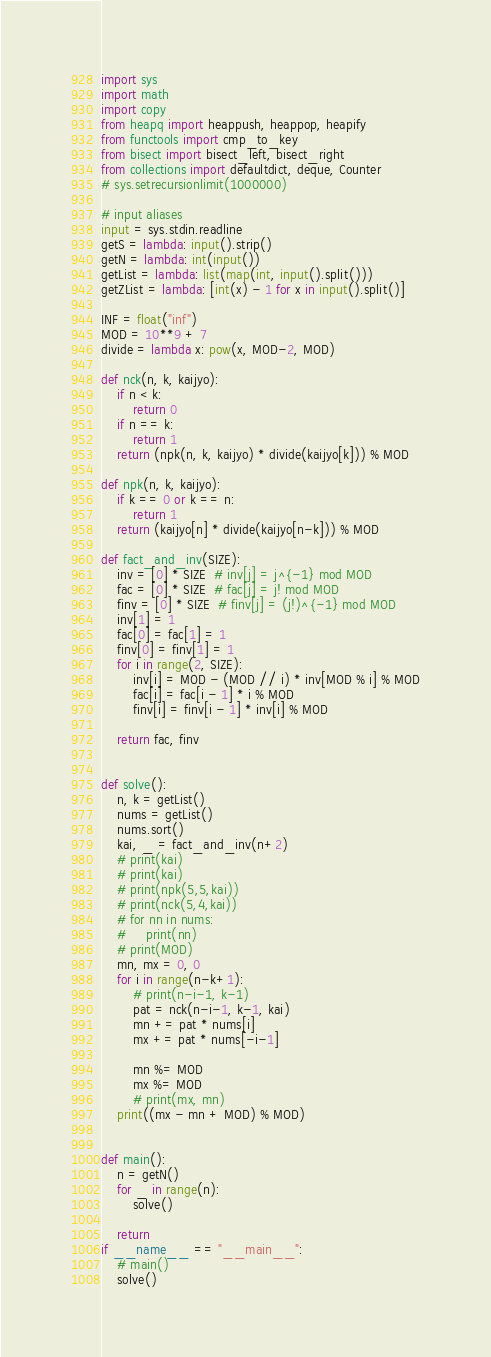<code> <loc_0><loc_0><loc_500><loc_500><_Python_>import sys
import math
import copy
from heapq import heappush, heappop, heapify
from functools import cmp_to_key
from bisect import bisect_left, bisect_right
from collections import defaultdict, deque, Counter
# sys.setrecursionlimit(1000000)

# input aliases
input = sys.stdin.readline
getS = lambda: input().strip()
getN = lambda: int(input())
getList = lambda: list(map(int, input().split()))
getZList = lambda: [int(x) - 1 for x in input().split()]

INF = float("inf")
MOD = 10**9 + 7
divide = lambda x: pow(x, MOD-2, MOD)

def nck(n, k, kaijyo):
    if n < k:
        return 0
    if n == k:
        return 1
    return (npk(n, k, kaijyo) * divide(kaijyo[k])) % MOD

def npk(n, k, kaijyo):
    if k == 0 or k == n:
        return 1
    return (kaijyo[n] * divide(kaijyo[n-k])) % MOD

def fact_and_inv(SIZE):
    inv = [0] * SIZE  # inv[j] = j^{-1} mod MOD
    fac = [0] * SIZE  # fac[j] = j! mod MOD
    finv = [0] * SIZE  # finv[j] = (j!)^{-1} mod MOD
    inv[1] = 1
    fac[0] = fac[1] = 1
    finv[0] = finv[1] = 1
    for i in range(2, SIZE):
        inv[i] = MOD - (MOD // i) * inv[MOD % i] % MOD
        fac[i] = fac[i - 1] * i % MOD
        finv[i] = finv[i - 1] * inv[i] % MOD

    return fac, finv


def solve():
    n, k = getList()
    nums = getList()
    nums.sort()
    kai, _ = fact_and_inv(n+2)
    # print(kai)
    # print(kai)
    # print(npk(5,5,kai))
    # print(nck(5,4,kai))
    # for nn in nums:
    #     print(nn)
    # print(MOD)
    mn, mx = 0, 0
    for i in range(n-k+1):
        # print(n-i-1, k-1)
        pat = nck(n-i-1, k-1, kai)
        mn += pat * nums[i]
        mx += pat * nums[-i-1]

        mn %= MOD
        mx %= MOD
        # print(mx, mn)
    print((mx - mn + MOD) % MOD)


def main():
    n = getN()
    for _ in range(n):
        solve()

    return
if __name__ == "__main__":
    # main()
    solve()





</code> 